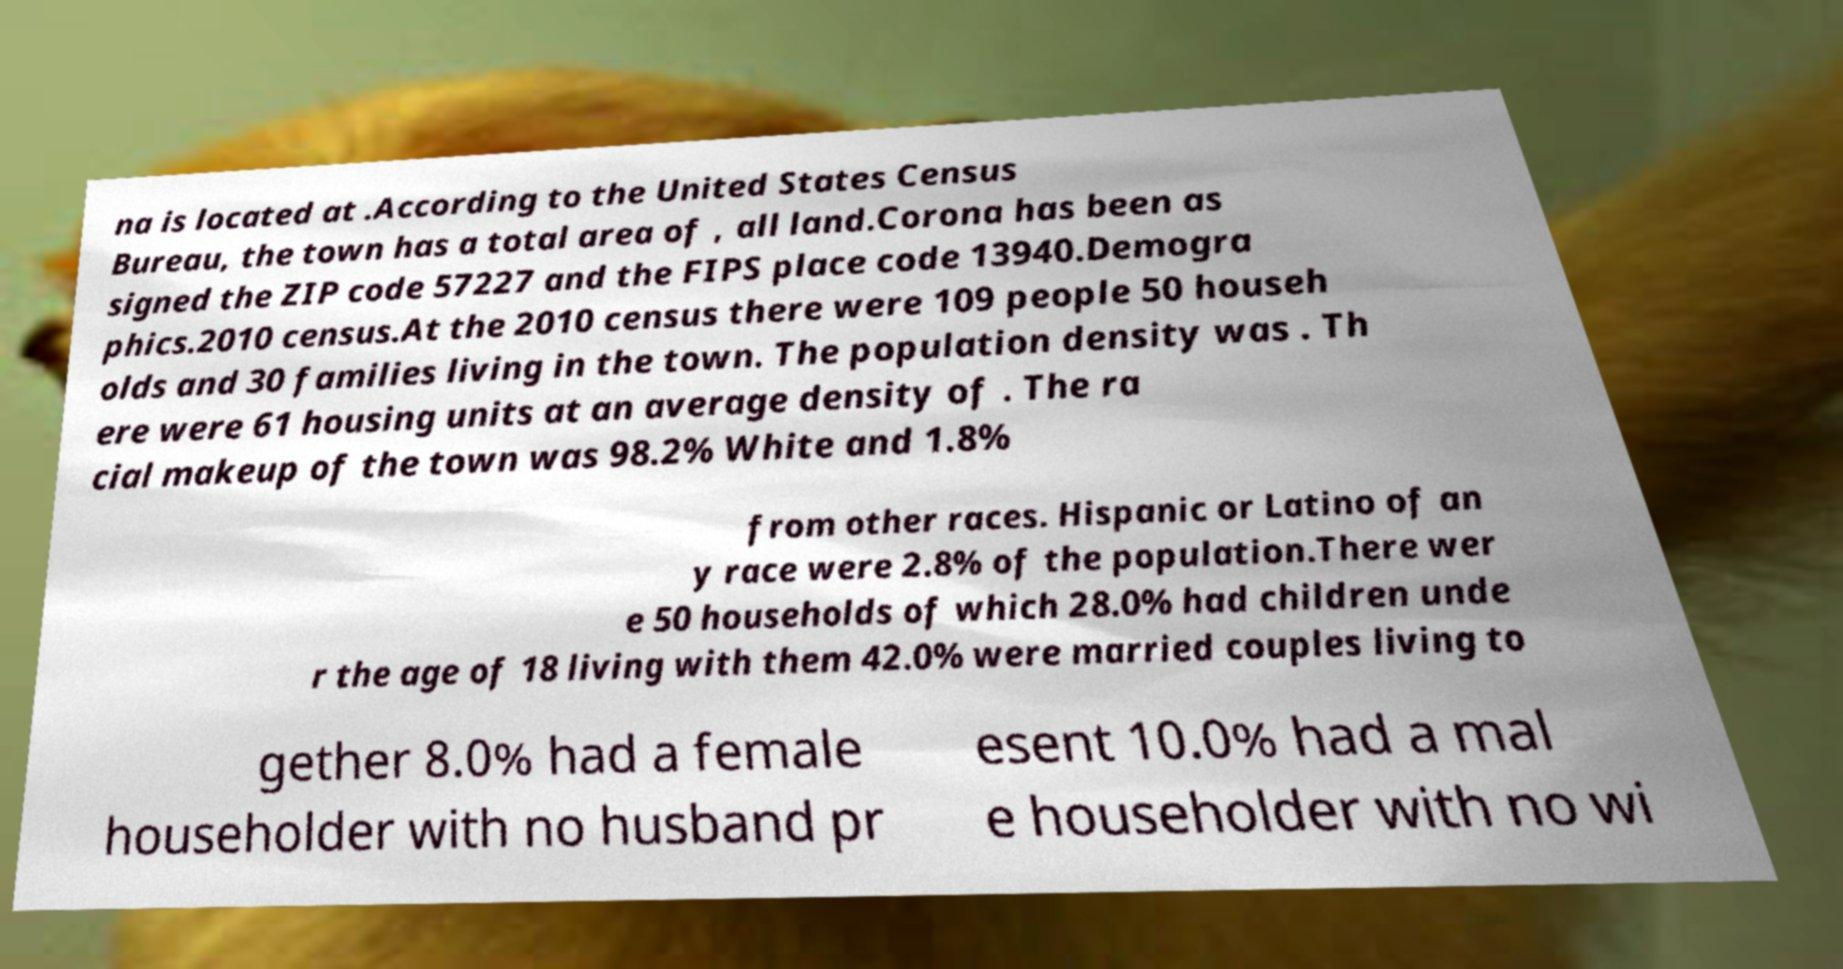Can you read and provide the text displayed in the image?This photo seems to have some interesting text. Can you extract and type it out for me? na is located at .According to the United States Census Bureau, the town has a total area of , all land.Corona has been as signed the ZIP code 57227 and the FIPS place code 13940.Demogra phics.2010 census.At the 2010 census there were 109 people 50 househ olds and 30 families living in the town. The population density was . Th ere were 61 housing units at an average density of . The ra cial makeup of the town was 98.2% White and 1.8% from other races. Hispanic or Latino of an y race were 2.8% of the population.There wer e 50 households of which 28.0% had children unde r the age of 18 living with them 42.0% were married couples living to gether 8.0% had a female householder with no husband pr esent 10.0% had a mal e householder with no wi 